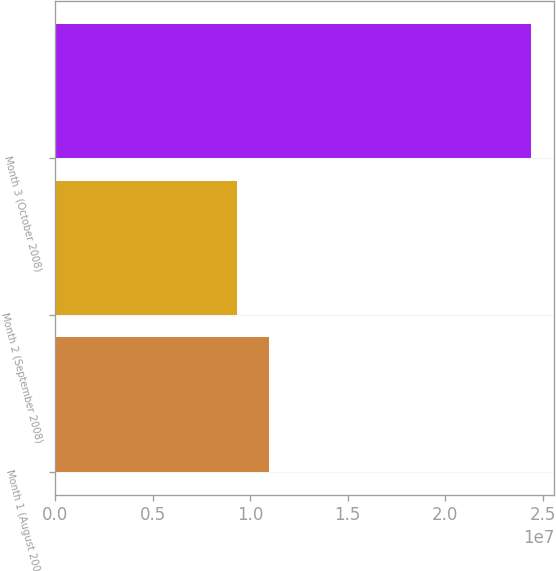<chart> <loc_0><loc_0><loc_500><loc_500><bar_chart><fcel>Month 1 (August 2008)<fcel>Month 2 (September 2008)<fcel>Month 3 (October 2008)<nl><fcel>1.09787e+07<fcel>9.32647e+06<fcel>2.43709e+07<nl></chart> 